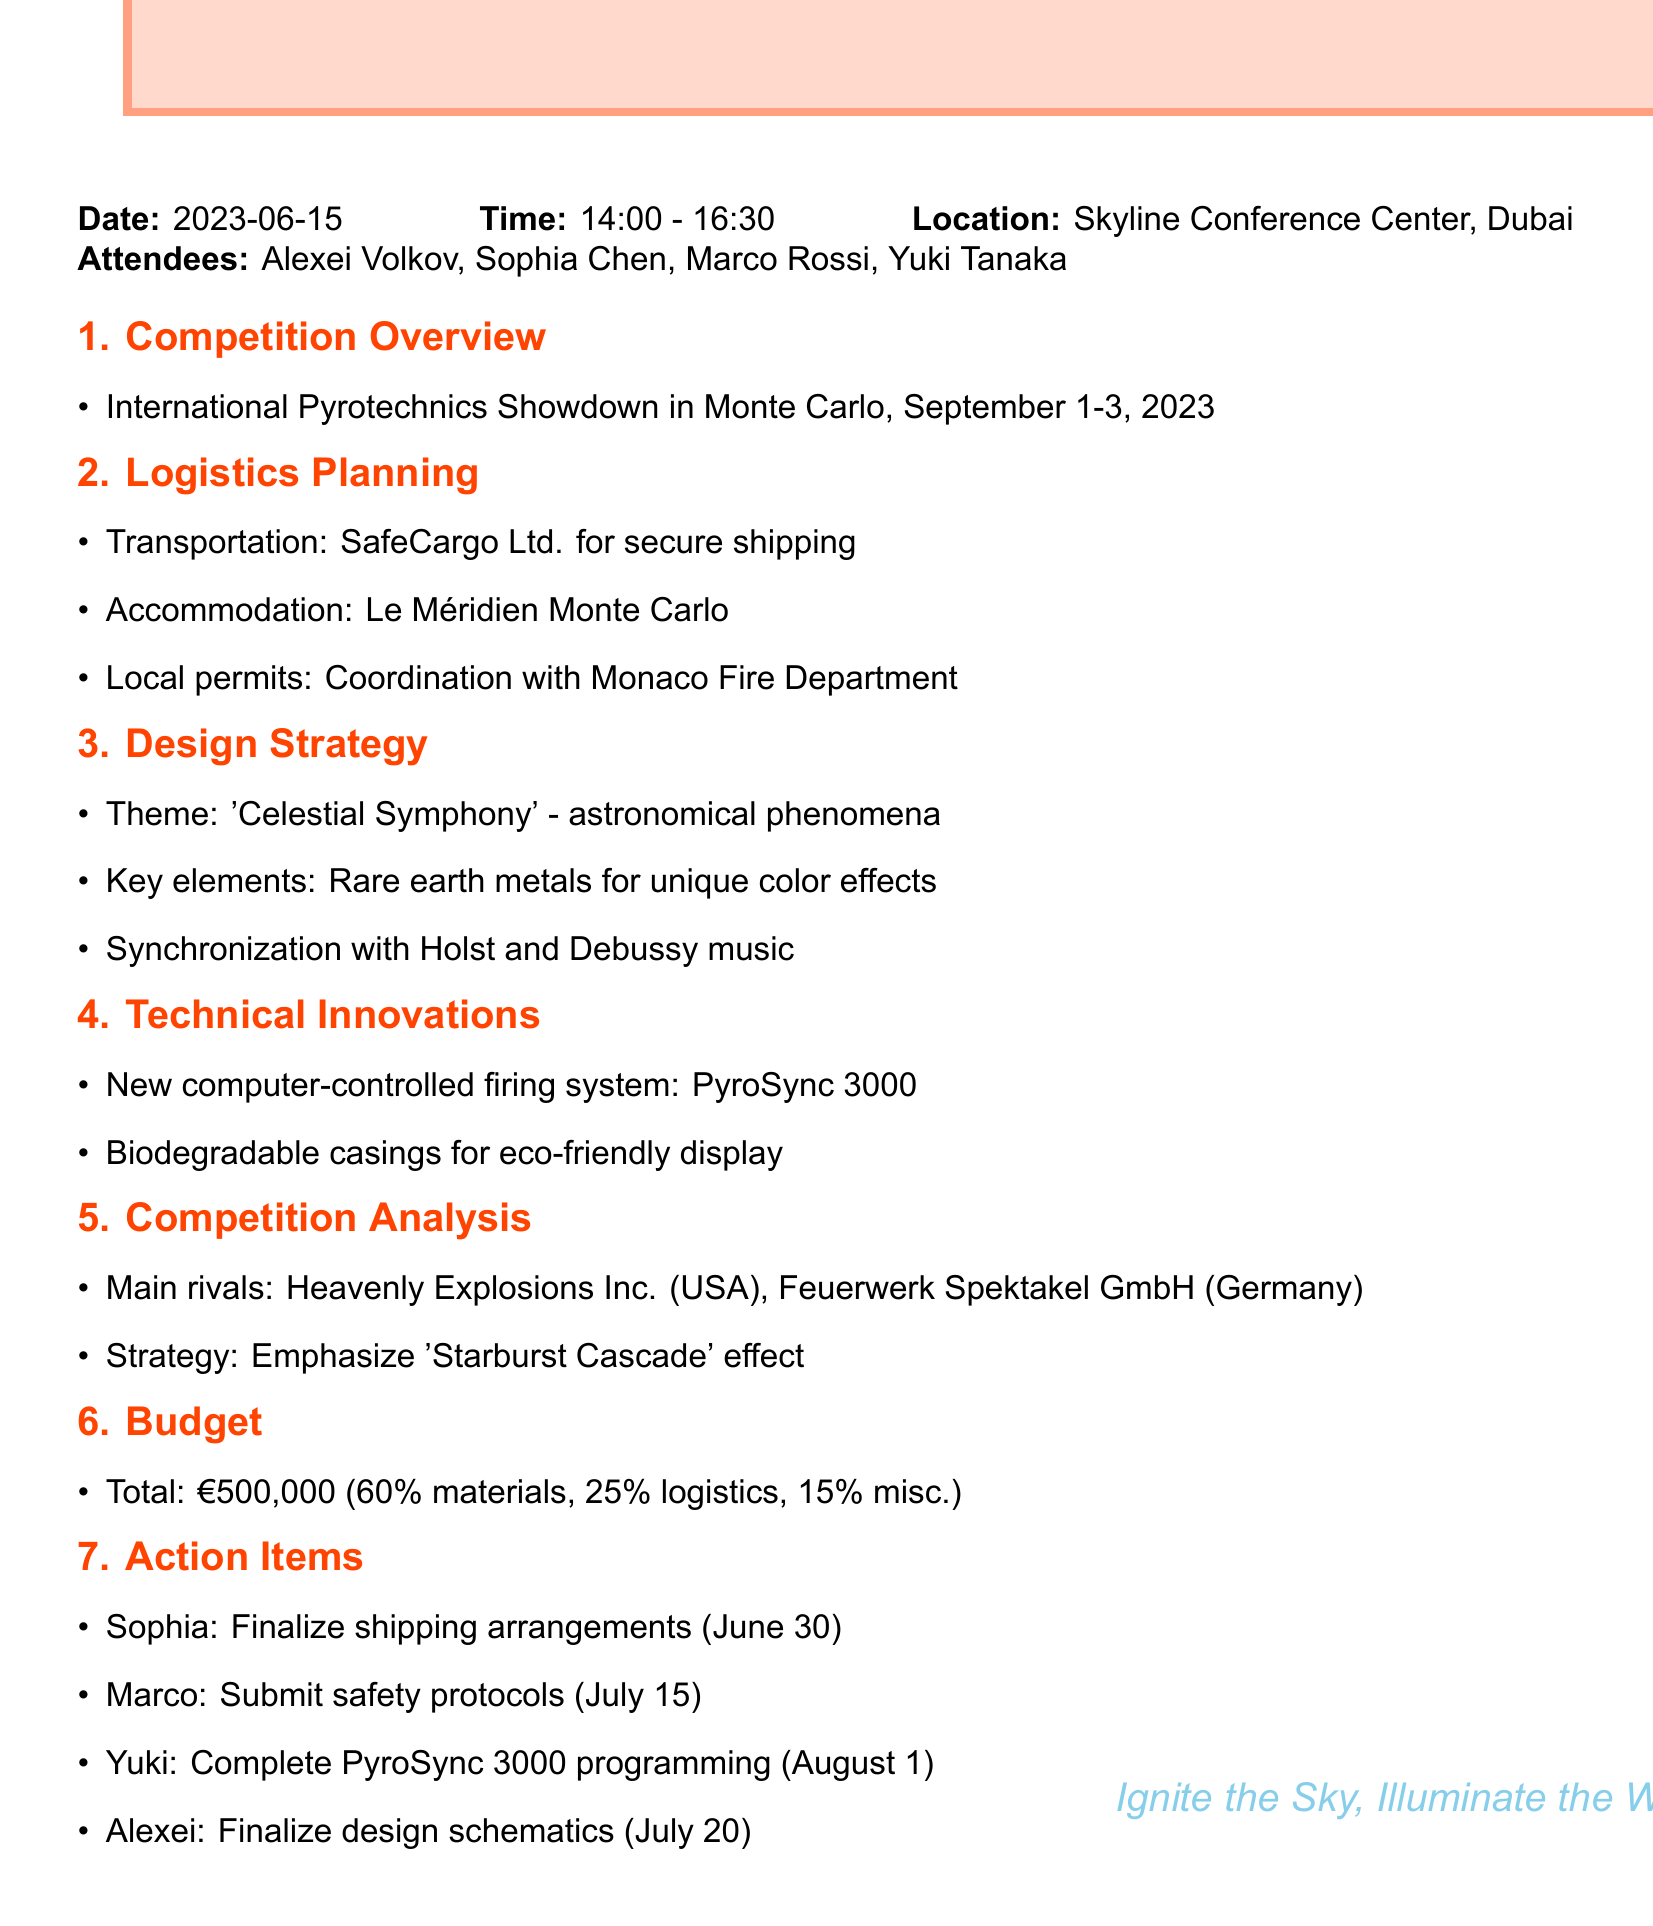What is the date of the meeting? The date of the meeting is explicitly stated in the document.
Answer: 2023-06-15 Who is the Logistics Coordinator? The document lists attendees including their roles, identifying the Logistics Coordinator.
Answer: Sophia Chen What is the total budget for the competition? The budget details are clearly outlined in the Budget section of the document.
Answer: €500,000 What is the theme of the design strategy? The design strategy section specifies the theme of the upcoming display.
Answer: 'Celestial Symphony' Which company is responsible for shipping arrangements? The document specifies the logistics planning details, including the transportation partner.
Answer: SafeCargo Ltd What percentage of the budget is allocated to materials? Budget allocation is provided in percentage within the Budget section.
Answer: 60% What is the deadline for Yuki to complete the PyroSync 3000 programming? The action items list a specific deadline for completing programming tasks.
Answer: August 1 Which two rivals are noted in the competition analysis? The document lists the main rivals under the Competition Analysis section.
Answer: Heavenly Explosions Inc. (USA) and Feuerwerk Spektakel GmbH (Germany) 